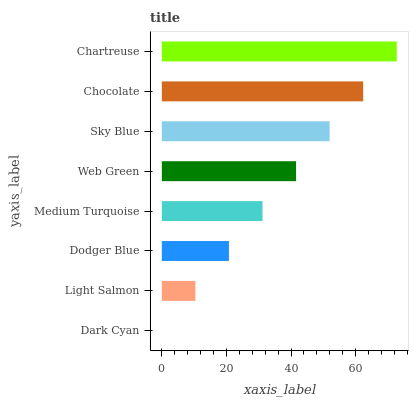Is Dark Cyan the minimum?
Answer yes or no. Yes. Is Chartreuse the maximum?
Answer yes or no. Yes. Is Light Salmon the minimum?
Answer yes or no. No. Is Light Salmon the maximum?
Answer yes or no. No. Is Light Salmon greater than Dark Cyan?
Answer yes or no. Yes. Is Dark Cyan less than Light Salmon?
Answer yes or no. Yes. Is Dark Cyan greater than Light Salmon?
Answer yes or no. No. Is Light Salmon less than Dark Cyan?
Answer yes or no. No. Is Web Green the high median?
Answer yes or no. Yes. Is Medium Turquoise the low median?
Answer yes or no. Yes. Is Dark Cyan the high median?
Answer yes or no. No. Is Web Green the low median?
Answer yes or no. No. 